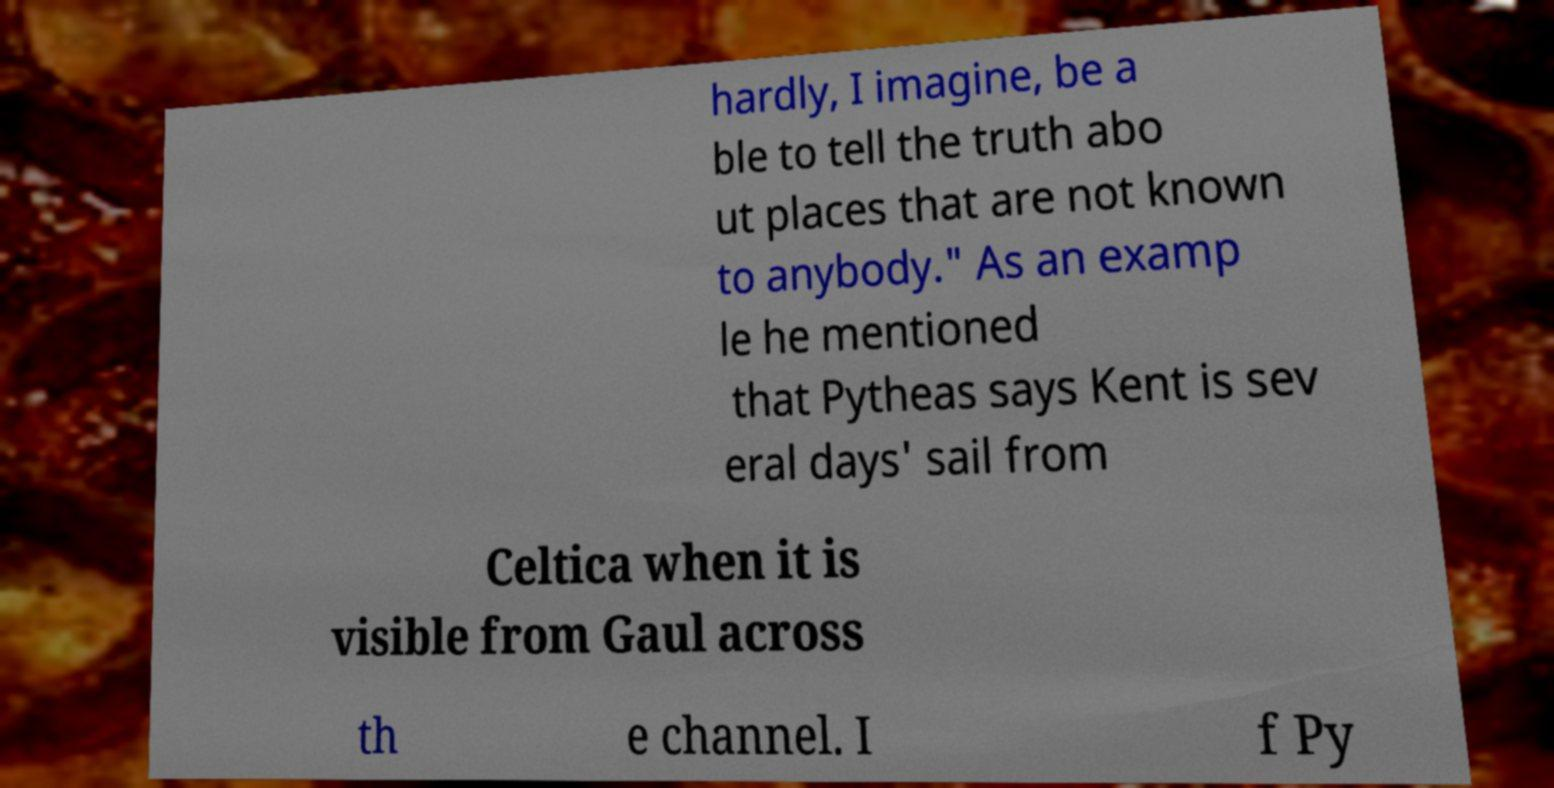For documentation purposes, I need the text within this image transcribed. Could you provide that? hardly, I imagine, be a ble to tell the truth abo ut places that are not known to anybody." As an examp le he mentioned that Pytheas says Kent is sev eral days' sail from Celtica when it is visible from Gaul across th e channel. I f Py 